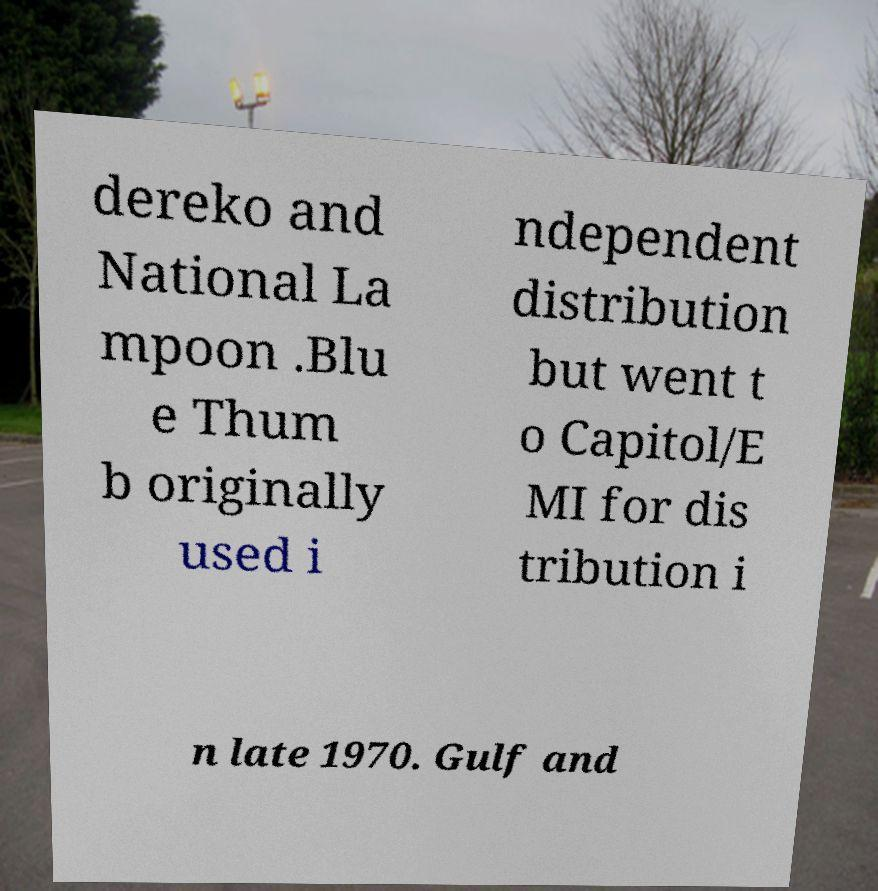Could you assist in decoding the text presented in this image and type it out clearly? dereko and National La mpoon .Blu e Thum b originally used i ndependent distribution but went t o Capitol/E MI for dis tribution i n late 1970. Gulf and 